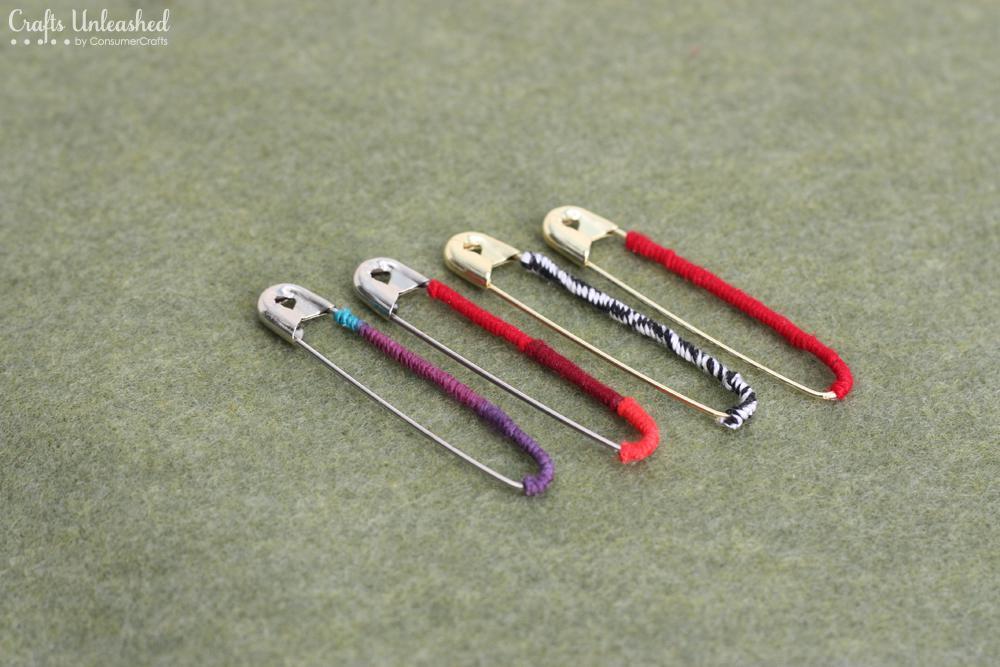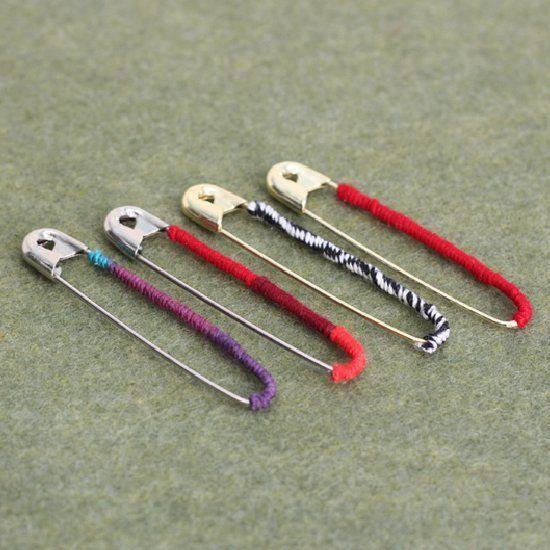The first image is the image on the left, the second image is the image on the right. Given the left and right images, does the statement "One safety pin is open and one is closed." hold true? Answer yes or no. No. The first image is the image on the left, the second image is the image on the right. For the images shown, is this caption "There are two safety pins" true? Answer yes or no. No. 